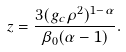<formula> <loc_0><loc_0><loc_500><loc_500>z = \frac { 3 ( g _ { c } \rho ^ { 2 } ) ^ { 1 - \alpha } } { \beta _ { 0 } ( \alpha - 1 ) } .</formula> 